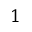Convert formula to latex. <formula><loc_0><loc_0><loc_500><loc_500>1</formula> 